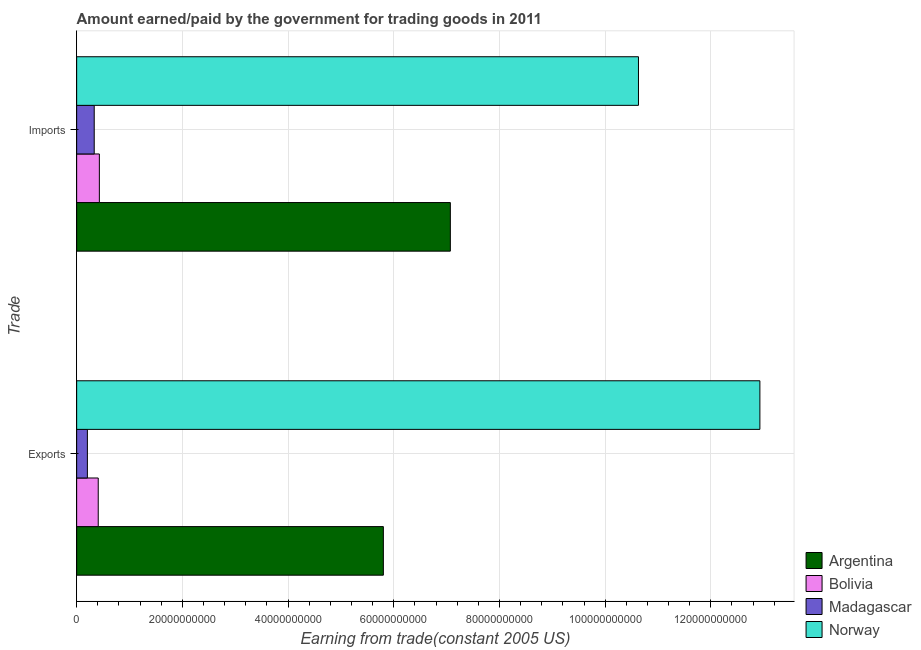How many different coloured bars are there?
Provide a succinct answer. 4. How many groups of bars are there?
Keep it short and to the point. 2. Are the number of bars on each tick of the Y-axis equal?
Provide a succinct answer. Yes. What is the label of the 1st group of bars from the top?
Your answer should be very brief. Imports. What is the amount earned from exports in Argentina?
Your answer should be very brief. 5.80e+1. Across all countries, what is the maximum amount earned from exports?
Your answer should be compact. 1.29e+11. Across all countries, what is the minimum amount paid for imports?
Your answer should be very brief. 3.32e+09. In which country was the amount paid for imports minimum?
Your answer should be compact. Madagascar. What is the total amount paid for imports in the graph?
Provide a short and direct response. 1.85e+11. What is the difference between the amount paid for imports in Madagascar and that in Norway?
Provide a succinct answer. -1.03e+11. What is the difference between the amount paid for imports in Norway and the amount earned from exports in Argentina?
Offer a terse response. 4.83e+1. What is the average amount paid for imports per country?
Offer a very short reply. 4.62e+1. What is the difference between the amount paid for imports and amount earned from exports in Madagascar?
Provide a short and direct response. 1.29e+09. What is the ratio of the amount earned from exports in Bolivia to that in Argentina?
Your answer should be very brief. 0.07. In how many countries, is the amount earned from exports greater than the average amount earned from exports taken over all countries?
Your answer should be very brief. 2. What does the 2nd bar from the top in Imports represents?
Your answer should be very brief. Madagascar. What does the 2nd bar from the bottom in Exports represents?
Your answer should be compact. Bolivia. Are all the bars in the graph horizontal?
Your answer should be very brief. Yes. What is the difference between two consecutive major ticks on the X-axis?
Offer a very short reply. 2.00e+1. Are the values on the major ticks of X-axis written in scientific E-notation?
Offer a very short reply. No. Does the graph contain grids?
Make the answer very short. Yes. Where does the legend appear in the graph?
Your response must be concise. Bottom right. What is the title of the graph?
Keep it short and to the point. Amount earned/paid by the government for trading goods in 2011. Does "Uruguay" appear as one of the legend labels in the graph?
Your response must be concise. No. What is the label or title of the X-axis?
Offer a terse response. Earning from trade(constant 2005 US). What is the label or title of the Y-axis?
Your answer should be compact. Trade. What is the Earning from trade(constant 2005 US) in Argentina in Exports?
Keep it short and to the point. 5.80e+1. What is the Earning from trade(constant 2005 US) of Bolivia in Exports?
Provide a succinct answer. 4.08e+09. What is the Earning from trade(constant 2005 US) of Madagascar in Exports?
Offer a very short reply. 2.03e+09. What is the Earning from trade(constant 2005 US) of Norway in Exports?
Offer a very short reply. 1.29e+11. What is the Earning from trade(constant 2005 US) of Argentina in Imports?
Offer a very short reply. 7.07e+1. What is the Earning from trade(constant 2005 US) in Bolivia in Imports?
Provide a short and direct response. 4.29e+09. What is the Earning from trade(constant 2005 US) in Madagascar in Imports?
Your answer should be compact. 3.32e+09. What is the Earning from trade(constant 2005 US) of Norway in Imports?
Your answer should be compact. 1.06e+11. Across all Trade, what is the maximum Earning from trade(constant 2005 US) of Argentina?
Keep it short and to the point. 7.07e+1. Across all Trade, what is the maximum Earning from trade(constant 2005 US) of Bolivia?
Make the answer very short. 4.29e+09. Across all Trade, what is the maximum Earning from trade(constant 2005 US) of Madagascar?
Provide a short and direct response. 3.32e+09. Across all Trade, what is the maximum Earning from trade(constant 2005 US) of Norway?
Offer a very short reply. 1.29e+11. Across all Trade, what is the minimum Earning from trade(constant 2005 US) of Argentina?
Your response must be concise. 5.80e+1. Across all Trade, what is the minimum Earning from trade(constant 2005 US) of Bolivia?
Keep it short and to the point. 4.08e+09. Across all Trade, what is the minimum Earning from trade(constant 2005 US) in Madagascar?
Your answer should be compact. 2.03e+09. Across all Trade, what is the minimum Earning from trade(constant 2005 US) in Norway?
Provide a succinct answer. 1.06e+11. What is the total Earning from trade(constant 2005 US) in Argentina in the graph?
Provide a short and direct response. 1.29e+11. What is the total Earning from trade(constant 2005 US) of Bolivia in the graph?
Your answer should be very brief. 8.38e+09. What is the total Earning from trade(constant 2005 US) of Madagascar in the graph?
Give a very brief answer. 5.35e+09. What is the total Earning from trade(constant 2005 US) of Norway in the graph?
Your answer should be very brief. 2.36e+11. What is the difference between the Earning from trade(constant 2005 US) of Argentina in Exports and that in Imports?
Your answer should be compact. -1.27e+1. What is the difference between the Earning from trade(constant 2005 US) in Bolivia in Exports and that in Imports?
Provide a succinct answer. -2.13e+08. What is the difference between the Earning from trade(constant 2005 US) in Madagascar in Exports and that in Imports?
Make the answer very short. -1.29e+09. What is the difference between the Earning from trade(constant 2005 US) in Norway in Exports and that in Imports?
Your answer should be very brief. 2.30e+1. What is the difference between the Earning from trade(constant 2005 US) of Argentina in Exports and the Earning from trade(constant 2005 US) of Bolivia in Imports?
Keep it short and to the point. 5.37e+1. What is the difference between the Earning from trade(constant 2005 US) in Argentina in Exports and the Earning from trade(constant 2005 US) in Madagascar in Imports?
Keep it short and to the point. 5.47e+1. What is the difference between the Earning from trade(constant 2005 US) in Argentina in Exports and the Earning from trade(constant 2005 US) in Norway in Imports?
Provide a short and direct response. -4.83e+1. What is the difference between the Earning from trade(constant 2005 US) of Bolivia in Exports and the Earning from trade(constant 2005 US) of Madagascar in Imports?
Offer a terse response. 7.58e+08. What is the difference between the Earning from trade(constant 2005 US) in Bolivia in Exports and the Earning from trade(constant 2005 US) in Norway in Imports?
Your response must be concise. -1.02e+11. What is the difference between the Earning from trade(constant 2005 US) in Madagascar in Exports and the Earning from trade(constant 2005 US) in Norway in Imports?
Keep it short and to the point. -1.04e+11. What is the average Earning from trade(constant 2005 US) of Argentina per Trade?
Your answer should be very brief. 6.44e+1. What is the average Earning from trade(constant 2005 US) in Bolivia per Trade?
Ensure brevity in your answer.  4.19e+09. What is the average Earning from trade(constant 2005 US) in Madagascar per Trade?
Your answer should be very brief. 2.68e+09. What is the average Earning from trade(constant 2005 US) in Norway per Trade?
Offer a very short reply. 1.18e+11. What is the difference between the Earning from trade(constant 2005 US) in Argentina and Earning from trade(constant 2005 US) in Bolivia in Exports?
Ensure brevity in your answer.  5.40e+1. What is the difference between the Earning from trade(constant 2005 US) of Argentina and Earning from trade(constant 2005 US) of Madagascar in Exports?
Provide a succinct answer. 5.60e+1. What is the difference between the Earning from trade(constant 2005 US) in Argentina and Earning from trade(constant 2005 US) in Norway in Exports?
Keep it short and to the point. -7.12e+1. What is the difference between the Earning from trade(constant 2005 US) in Bolivia and Earning from trade(constant 2005 US) in Madagascar in Exports?
Provide a short and direct response. 2.05e+09. What is the difference between the Earning from trade(constant 2005 US) in Bolivia and Earning from trade(constant 2005 US) in Norway in Exports?
Give a very brief answer. -1.25e+11. What is the difference between the Earning from trade(constant 2005 US) in Madagascar and Earning from trade(constant 2005 US) in Norway in Exports?
Your answer should be very brief. -1.27e+11. What is the difference between the Earning from trade(constant 2005 US) in Argentina and Earning from trade(constant 2005 US) in Bolivia in Imports?
Your response must be concise. 6.64e+1. What is the difference between the Earning from trade(constant 2005 US) in Argentina and Earning from trade(constant 2005 US) in Madagascar in Imports?
Your answer should be compact. 6.74e+1. What is the difference between the Earning from trade(constant 2005 US) of Argentina and Earning from trade(constant 2005 US) of Norway in Imports?
Offer a terse response. -3.56e+1. What is the difference between the Earning from trade(constant 2005 US) of Bolivia and Earning from trade(constant 2005 US) of Madagascar in Imports?
Make the answer very short. 9.71e+08. What is the difference between the Earning from trade(constant 2005 US) of Bolivia and Earning from trade(constant 2005 US) of Norway in Imports?
Make the answer very short. -1.02e+11. What is the difference between the Earning from trade(constant 2005 US) in Madagascar and Earning from trade(constant 2005 US) in Norway in Imports?
Give a very brief answer. -1.03e+11. What is the ratio of the Earning from trade(constant 2005 US) in Argentina in Exports to that in Imports?
Your answer should be compact. 0.82. What is the ratio of the Earning from trade(constant 2005 US) in Bolivia in Exports to that in Imports?
Offer a terse response. 0.95. What is the ratio of the Earning from trade(constant 2005 US) in Madagascar in Exports to that in Imports?
Offer a terse response. 0.61. What is the ratio of the Earning from trade(constant 2005 US) of Norway in Exports to that in Imports?
Your response must be concise. 1.22. What is the difference between the highest and the second highest Earning from trade(constant 2005 US) in Argentina?
Your answer should be very brief. 1.27e+1. What is the difference between the highest and the second highest Earning from trade(constant 2005 US) of Bolivia?
Ensure brevity in your answer.  2.13e+08. What is the difference between the highest and the second highest Earning from trade(constant 2005 US) in Madagascar?
Ensure brevity in your answer.  1.29e+09. What is the difference between the highest and the second highest Earning from trade(constant 2005 US) in Norway?
Give a very brief answer. 2.30e+1. What is the difference between the highest and the lowest Earning from trade(constant 2005 US) of Argentina?
Keep it short and to the point. 1.27e+1. What is the difference between the highest and the lowest Earning from trade(constant 2005 US) of Bolivia?
Your answer should be compact. 2.13e+08. What is the difference between the highest and the lowest Earning from trade(constant 2005 US) of Madagascar?
Provide a short and direct response. 1.29e+09. What is the difference between the highest and the lowest Earning from trade(constant 2005 US) in Norway?
Your answer should be very brief. 2.30e+1. 